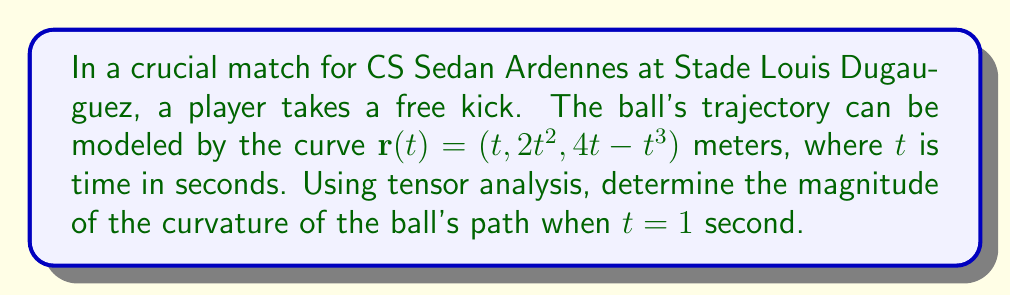Give your solution to this math problem. To find the curvature of the ball's trajectory, we'll follow these steps:

1) The curvature $\kappa$ is given by:

   $$\kappa = \frac{\sqrt{|\mathbf{r}'(t) \times \mathbf{r}''(t)|^2}}{|\mathbf{r}'(t)|^3}$$

2) First, let's calculate $\mathbf{r}'(t)$:
   $$\mathbf{r}'(t) = (1, 4t, 4 - 3t^2)$$

3) Next, calculate $\mathbf{r}''(t)$:
   $$\mathbf{r}''(t) = (0, 4, -6t)$$

4) Now, we need to compute $\mathbf{r}'(t) \times \mathbf{r}''(t)$:
   $$\mathbf{r}'(t) \times \mathbf{r}''(t) = \begin{vmatrix} 
   \mathbf{i} & \mathbf{j} & \mathbf{k} \\
   1 & 4t & 4-3t^2 \\
   0 & 4 & -6t
   \end{vmatrix}$$

   $$= (-24t-16+12t^3)\mathbf{i} + (6t)\mathbf{j} + (-4)\mathbf{k}$$

5) The magnitude squared of this cross product is:
   $$|\mathbf{r}'(t) \times \mathbf{r}''(t)|^2 = (-24t-16+12t^3)^2 + (6t)^2 + (-4)^2$$

6) The magnitude of $\mathbf{r}'(t)$ is:
   $$|\mathbf{r}'(t)| = \sqrt{1^2 + (4t)^2 + (4-3t^2)^2}$$

7) Substituting $t=1$ into these expressions:

   $$|\mathbf{r}'(1) \times \mathbf{r}''(1)|^2 = (-28+12)^2 + 6^2 + (-4)^2 = 324$$
   
   $$|\mathbf{r}'(1)| = \sqrt{1^2 + 4^2 + 1^2} = \sqrt{18}$$

8) Therefore, the curvature at $t=1$ is:

   $$\kappa = \frac{\sqrt{324}}{(\sqrt{18})^3} = \frac{18}{54} = \frac{1}{3}$$
Answer: $\frac{1}{3}$ m$^{-1}$ 